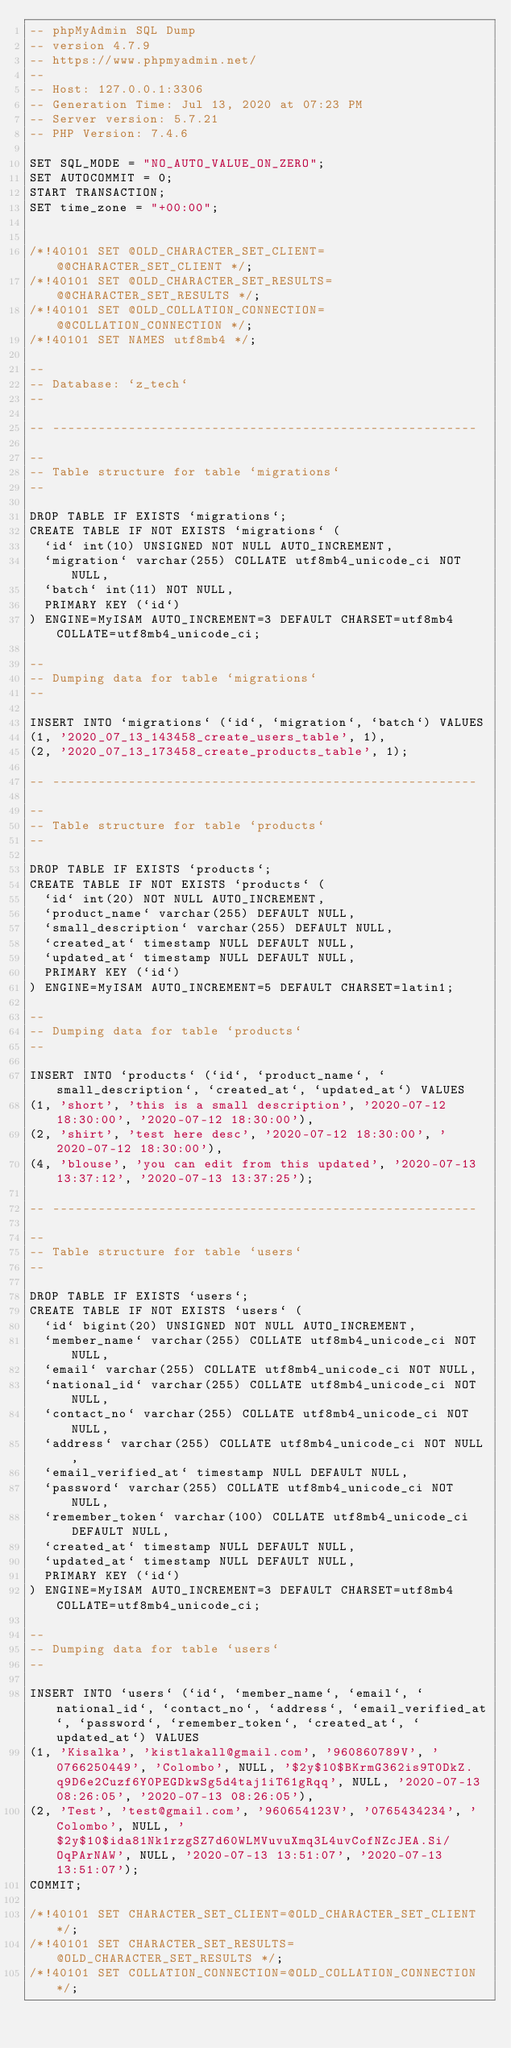Convert code to text. <code><loc_0><loc_0><loc_500><loc_500><_SQL_>-- phpMyAdmin SQL Dump
-- version 4.7.9
-- https://www.phpmyadmin.net/
--
-- Host: 127.0.0.1:3306
-- Generation Time: Jul 13, 2020 at 07:23 PM
-- Server version: 5.7.21
-- PHP Version: 7.4.6

SET SQL_MODE = "NO_AUTO_VALUE_ON_ZERO";
SET AUTOCOMMIT = 0;
START TRANSACTION;
SET time_zone = "+00:00";


/*!40101 SET @OLD_CHARACTER_SET_CLIENT=@@CHARACTER_SET_CLIENT */;
/*!40101 SET @OLD_CHARACTER_SET_RESULTS=@@CHARACTER_SET_RESULTS */;
/*!40101 SET @OLD_COLLATION_CONNECTION=@@COLLATION_CONNECTION */;
/*!40101 SET NAMES utf8mb4 */;

--
-- Database: `z_tech`
--

-- --------------------------------------------------------

--
-- Table structure for table `migrations`
--

DROP TABLE IF EXISTS `migrations`;
CREATE TABLE IF NOT EXISTS `migrations` (
  `id` int(10) UNSIGNED NOT NULL AUTO_INCREMENT,
  `migration` varchar(255) COLLATE utf8mb4_unicode_ci NOT NULL,
  `batch` int(11) NOT NULL,
  PRIMARY KEY (`id`)
) ENGINE=MyISAM AUTO_INCREMENT=3 DEFAULT CHARSET=utf8mb4 COLLATE=utf8mb4_unicode_ci;

--
-- Dumping data for table `migrations`
--

INSERT INTO `migrations` (`id`, `migration`, `batch`) VALUES
(1, '2020_07_13_143458_create_users_table', 1),
(2, '2020_07_13_173458_create_products_table', 1);

-- --------------------------------------------------------

--
-- Table structure for table `products`
--

DROP TABLE IF EXISTS `products`;
CREATE TABLE IF NOT EXISTS `products` (
  `id` int(20) NOT NULL AUTO_INCREMENT,
  `product_name` varchar(255) DEFAULT NULL,
  `small_description` varchar(255) DEFAULT NULL,
  `created_at` timestamp NULL DEFAULT NULL,
  `updated_at` timestamp NULL DEFAULT NULL,
  PRIMARY KEY (`id`)
) ENGINE=MyISAM AUTO_INCREMENT=5 DEFAULT CHARSET=latin1;

--
-- Dumping data for table `products`
--

INSERT INTO `products` (`id`, `product_name`, `small_description`, `created_at`, `updated_at`) VALUES
(1, 'short', 'this is a small description', '2020-07-12 18:30:00', '2020-07-12 18:30:00'),
(2, 'shirt', 'test here desc', '2020-07-12 18:30:00', '2020-07-12 18:30:00'),
(4, 'blouse', 'you can edit from this updated', '2020-07-13 13:37:12', '2020-07-13 13:37:25');

-- --------------------------------------------------------

--
-- Table structure for table `users`
--

DROP TABLE IF EXISTS `users`;
CREATE TABLE IF NOT EXISTS `users` (
  `id` bigint(20) UNSIGNED NOT NULL AUTO_INCREMENT,
  `member_name` varchar(255) COLLATE utf8mb4_unicode_ci NOT NULL,
  `email` varchar(255) COLLATE utf8mb4_unicode_ci NOT NULL,
  `national_id` varchar(255) COLLATE utf8mb4_unicode_ci NOT NULL,
  `contact_no` varchar(255) COLLATE utf8mb4_unicode_ci NOT NULL,
  `address` varchar(255) COLLATE utf8mb4_unicode_ci NOT NULL,
  `email_verified_at` timestamp NULL DEFAULT NULL,
  `password` varchar(255) COLLATE utf8mb4_unicode_ci NOT NULL,
  `remember_token` varchar(100) COLLATE utf8mb4_unicode_ci DEFAULT NULL,
  `created_at` timestamp NULL DEFAULT NULL,
  `updated_at` timestamp NULL DEFAULT NULL,
  PRIMARY KEY (`id`)
) ENGINE=MyISAM AUTO_INCREMENT=3 DEFAULT CHARSET=utf8mb4 COLLATE=utf8mb4_unicode_ci;

--
-- Dumping data for table `users`
--

INSERT INTO `users` (`id`, `member_name`, `email`, `national_id`, `contact_no`, `address`, `email_verified_at`, `password`, `remember_token`, `created_at`, `updated_at`) VALUES
(1, 'Kisalka', 'kistlakall@gmail.com', '960860789V', '0766250449', 'Colombo', NULL, '$2y$10$BKrmG362is9T0DkZ.q9D6e2Cuzf6Y0PEGDkwSg5d4taj1iT61gRqq', NULL, '2020-07-13 08:26:05', '2020-07-13 08:26:05'),
(2, 'Test', 'test@gmail.com', '960654123V', '0765434234', 'Colombo', NULL, '$2y$10$ida81Nk1rzgSZ7d60WLMVuvuXmq3L4uvCofNZcJEA.Si/OqPArNAW', NULL, '2020-07-13 13:51:07', '2020-07-13 13:51:07');
COMMIT;

/*!40101 SET CHARACTER_SET_CLIENT=@OLD_CHARACTER_SET_CLIENT */;
/*!40101 SET CHARACTER_SET_RESULTS=@OLD_CHARACTER_SET_RESULTS */;
/*!40101 SET COLLATION_CONNECTION=@OLD_COLLATION_CONNECTION */;
</code> 